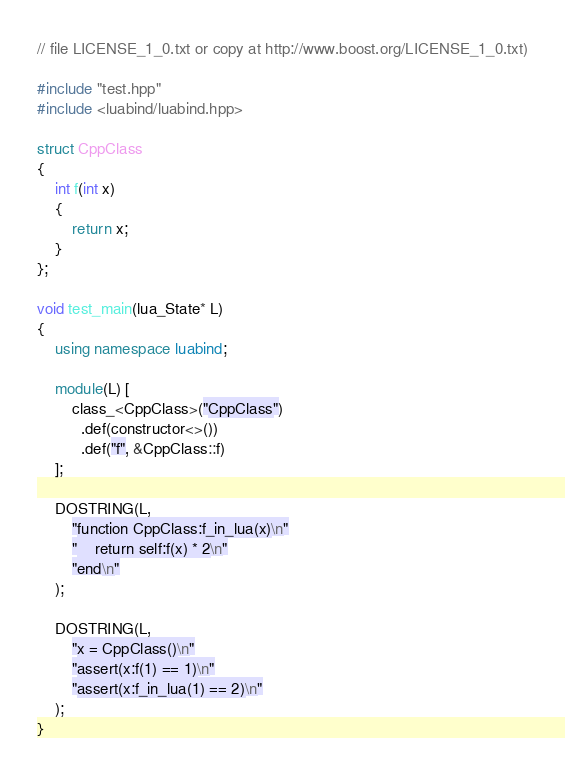Convert code to text. <code><loc_0><loc_0><loc_500><loc_500><_C++_>// file LICENSE_1_0.txt or copy at http://www.boost.org/LICENSE_1_0.txt)

#include "test.hpp"
#include <luabind/luabind.hpp>

struct CppClass
{
    int f(int x)
    {
        return x;
    }
};

void test_main(lua_State* L)
{
    using namespace luabind;

    module(L) [
        class_<CppClass>("CppClass")
          .def(constructor<>())
          .def("f", &CppClass::f)
    ];

    DOSTRING(L,
        "function CppClass:f_in_lua(x)\n"
        "    return self:f(x) * 2\n"
        "end\n"
    );

    DOSTRING(L,
        "x = CppClass()\n"
        "assert(x:f(1) == 1)\n"
        "assert(x:f_in_lua(1) == 2)\n"
    );
}
</code> 